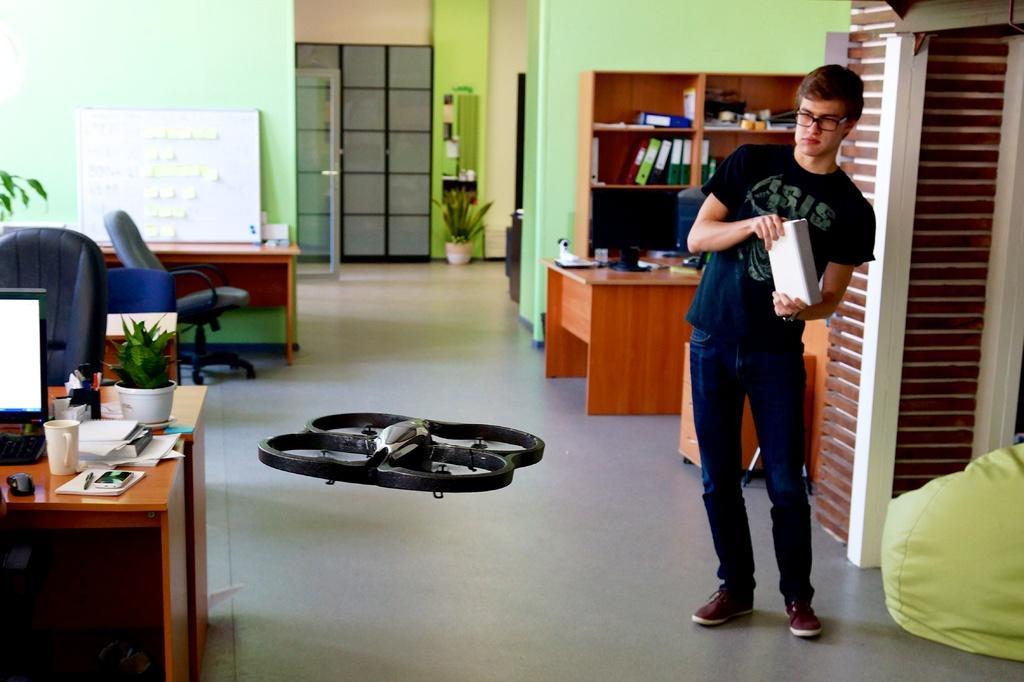How would you summarize this image in a sentence or two? In this image there is a person standing at the left side of the image there is a system and at the background of the image there are books 